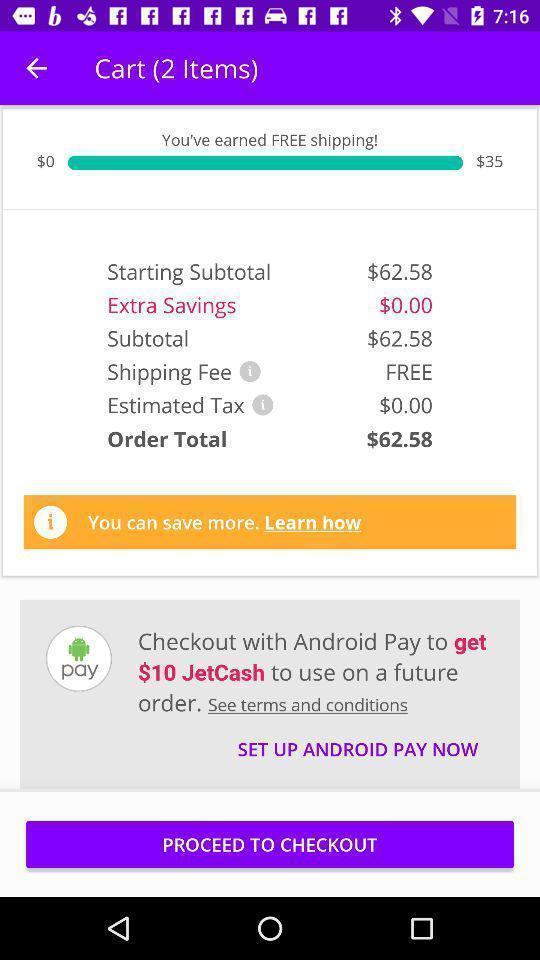Summarize the information in this screenshot. Page showing information about cart items. 